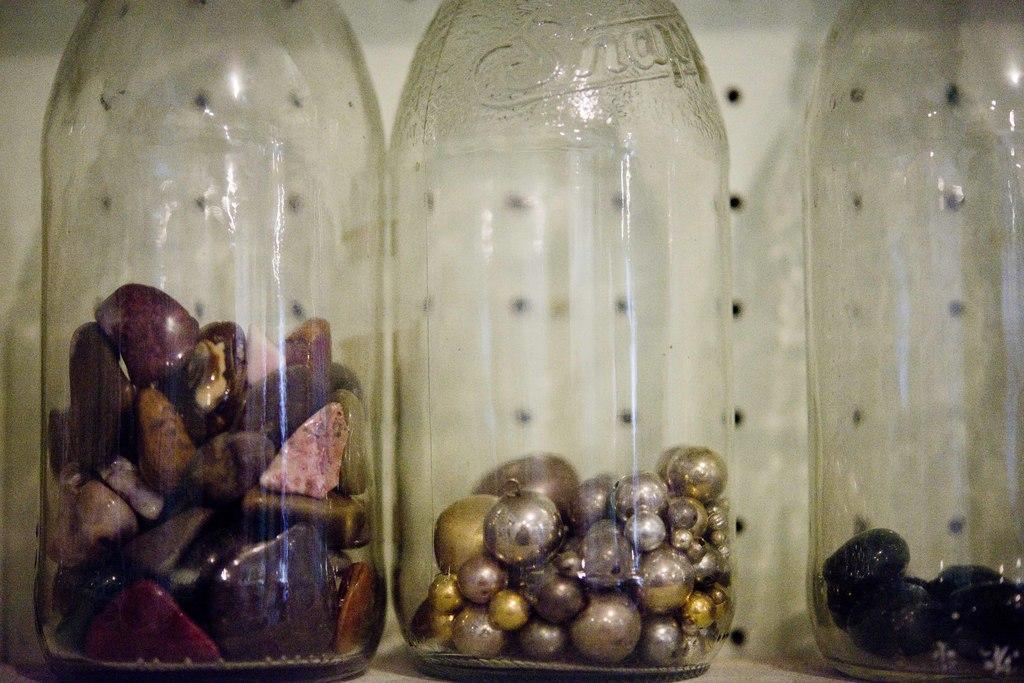<image>
Summarize the visual content of the image. colorful beads and gems in old Snapple bottles 